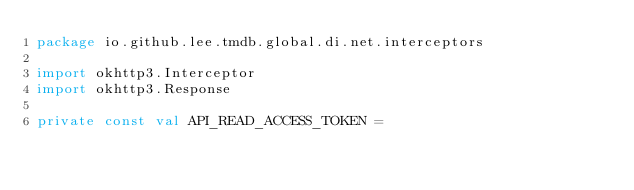<code> <loc_0><loc_0><loc_500><loc_500><_Kotlin_>package io.github.lee.tmdb.global.di.net.interceptors

import okhttp3.Interceptor
import okhttp3.Response

private const val API_READ_ACCESS_TOKEN =</code> 